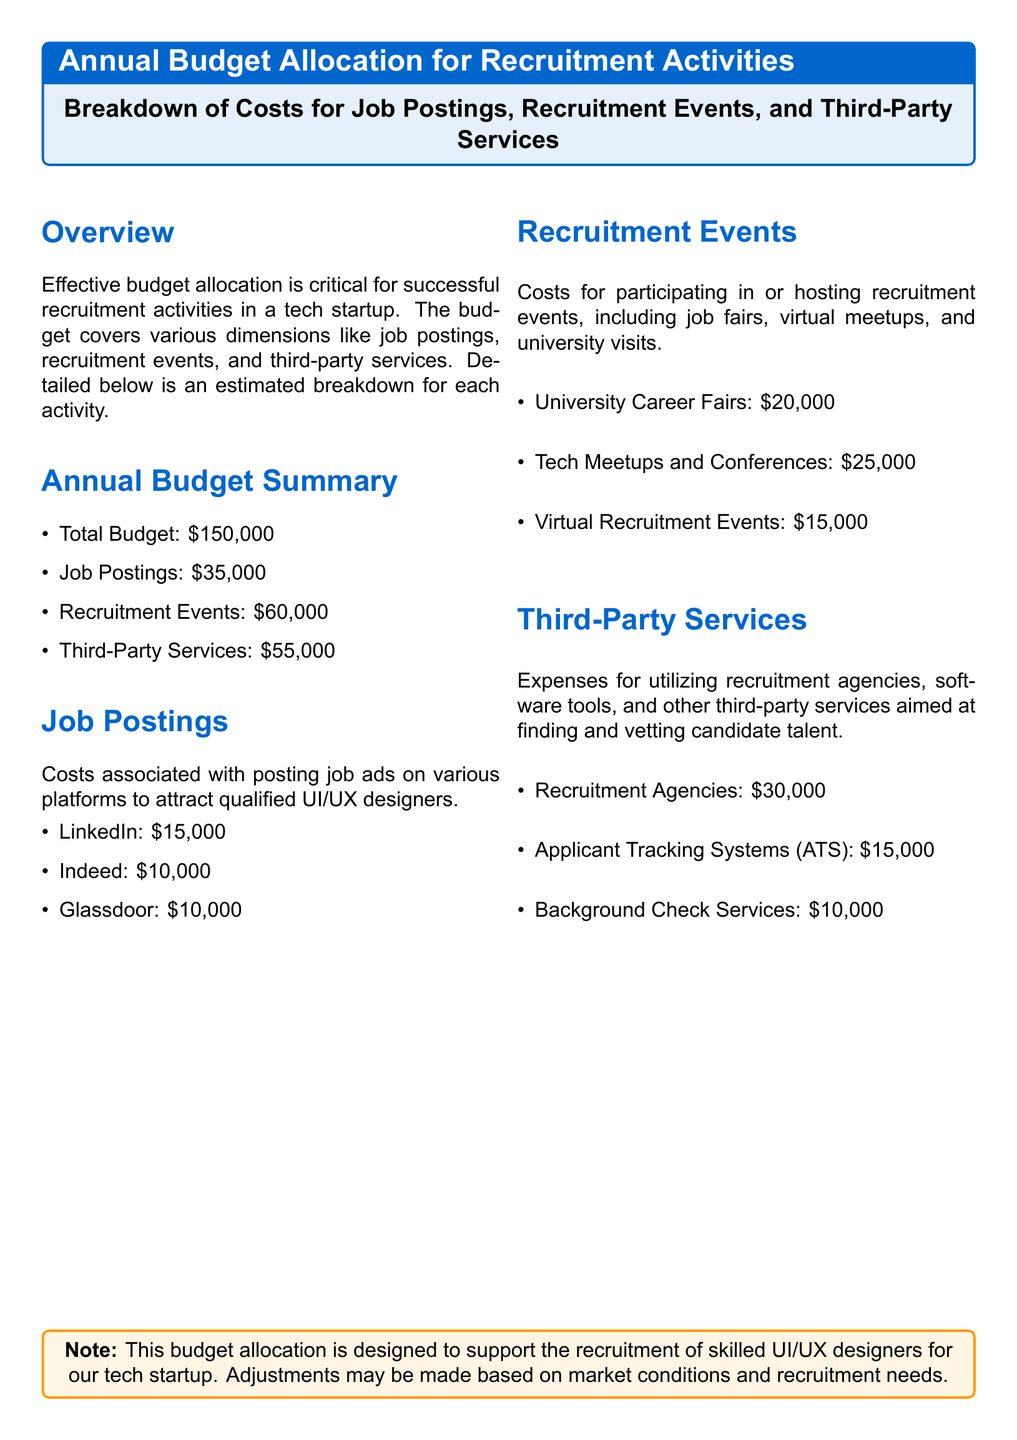what is the total budget? The total budget is explicitly stated in the document.
Answer: $150,000 how much is allocated for job postings? The document lists the budget allocated specifically for job postings.
Answer: $35,000 what is the cost for university career fairs? The cost associated with university career fairs is detailed in the recruitment events section.
Answer: $20,000 how much is spent on third-party services? The total amount allocated for third-party services is provided in the budget summary.
Answer: $55,000 which job posting platform has the highest cost? The document outlines the costs for three job posting platforms, and the highest is evident.
Answer: LinkedIn what is the combined cost for recruitment events? This requires adding up the individual costs for various recruitment events mentioned.
Answer: $60,000 how much is allocated for background check services? The specific cost for background check services is listed in the third-party services section.
Answer: $10,000 what percentage of the total budget is spent on recruitment events? This is derived from calculating the ratio of the recruitment events budget to the total budget.
Answer: 40% which recruitment agency has the highest cost? The individual costs for recruitment agencies are detailed, allowing for comparison.
Answer: Recruitment Agencies 